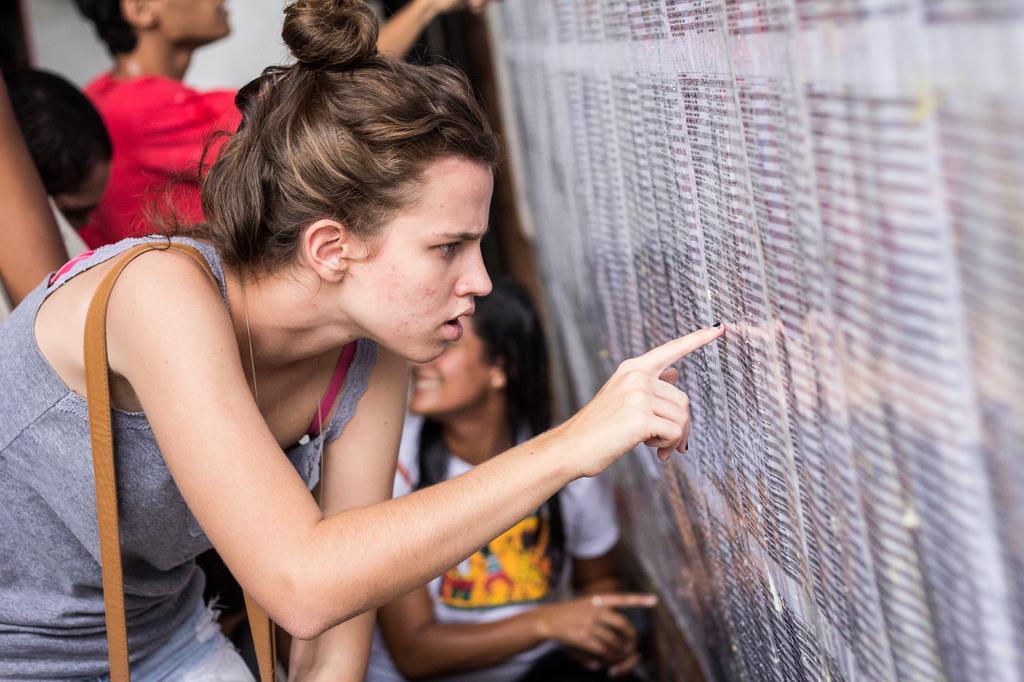Can you describe this image briefly? In the center of the image we can see a few people are in different costumes. On the right side of the image, there is a wall with some text. In the background, we can see it is blurred. 